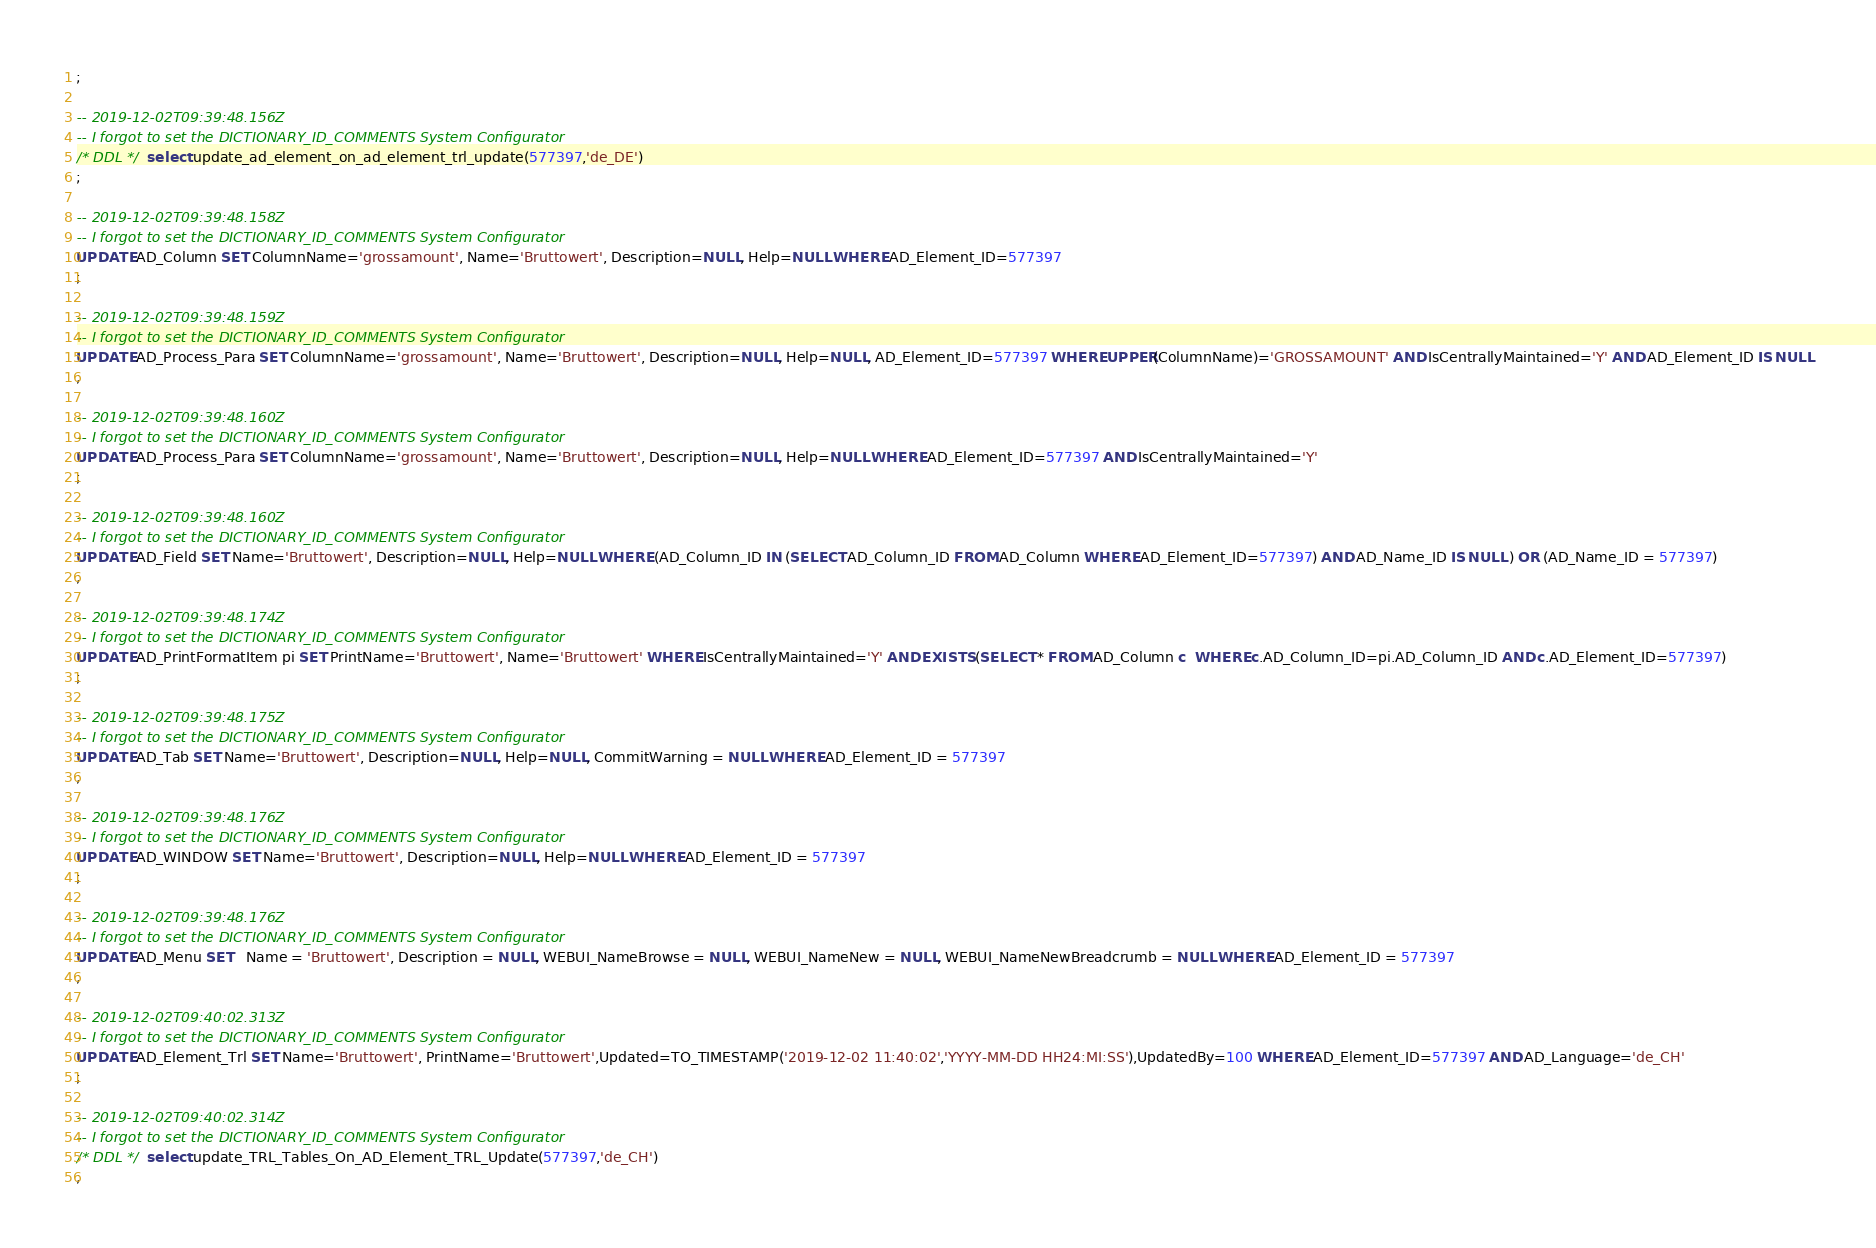<code> <loc_0><loc_0><loc_500><loc_500><_SQL_>;

-- 2019-12-02T09:39:48.156Z
-- I forgot to set the DICTIONARY_ID_COMMENTS System Configurator
/* DDL */  select update_ad_element_on_ad_element_trl_update(577397,'de_DE') 
;

-- 2019-12-02T09:39:48.158Z
-- I forgot to set the DICTIONARY_ID_COMMENTS System Configurator
UPDATE AD_Column SET ColumnName='grossamount', Name='Bruttowert', Description=NULL, Help=NULL WHERE AD_Element_ID=577397
;

-- 2019-12-02T09:39:48.159Z
-- I forgot to set the DICTIONARY_ID_COMMENTS System Configurator
UPDATE AD_Process_Para SET ColumnName='grossamount', Name='Bruttowert', Description=NULL, Help=NULL, AD_Element_ID=577397 WHERE UPPER(ColumnName)='GROSSAMOUNT' AND IsCentrallyMaintained='Y' AND AD_Element_ID IS NULL
;

-- 2019-12-02T09:39:48.160Z
-- I forgot to set the DICTIONARY_ID_COMMENTS System Configurator
UPDATE AD_Process_Para SET ColumnName='grossamount', Name='Bruttowert', Description=NULL, Help=NULL WHERE AD_Element_ID=577397 AND IsCentrallyMaintained='Y'
;

-- 2019-12-02T09:39:48.160Z
-- I forgot to set the DICTIONARY_ID_COMMENTS System Configurator
UPDATE AD_Field SET Name='Bruttowert', Description=NULL, Help=NULL WHERE (AD_Column_ID IN (SELECT AD_Column_ID FROM AD_Column WHERE AD_Element_ID=577397) AND AD_Name_ID IS NULL ) OR (AD_Name_ID = 577397)
;

-- 2019-12-02T09:39:48.174Z
-- I forgot to set the DICTIONARY_ID_COMMENTS System Configurator
UPDATE AD_PrintFormatItem pi SET PrintName='Bruttowert', Name='Bruttowert' WHERE IsCentrallyMaintained='Y' AND EXISTS (SELECT * FROM AD_Column c  WHERE c.AD_Column_ID=pi.AD_Column_ID AND c.AD_Element_ID=577397)
;

-- 2019-12-02T09:39:48.175Z
-- I forgot to set the DICTIONARY_ID_COMMENTS System Configurator
UPDATE AD_Tab SET Name='Bruttowert', Description=NULL, Help=NULL, CommitWarning = NULL WHERE AD_Element_ID = 577397
;

-- 2019-12-02T09:39:48.176Z
-- I forgot to set the DICTIONARY_ID_COMMENTS System Configurator
UPDATE AD_WINDOW SET Name='Bruttowert', Description=NULL, Help=NULL WHERE AD_Element_ID = 577397
;

-- 2019-12-02T09:39:48.176Z
-- I forgot to set the DICTIONARY_ID_COMMENTS System Configurator
UPDATE AD_Menu SET   Name = 'Bruttowert', Description = NULL, WEBUI_NameBrowse = NULL, WEBUI_NameNew = NULL, WEBUI_NameNewBreadcrumb = NULL WHERE AD_Element_ID = 577397
;

-- 2019-12-02T09:40:02.313Z
-- I forgot to set the DICTIONARY_ID_COMMENTS System Configurator
UPDATE AD_Element_Trl SET Name='Bruttowert', PrintName='Bruttowert',Updated=TO_TIMESTAMP('2019-12-02 11:40:02','YYYY-MM-DD HH24:MI:SS'),UpdatedBy=100 WHERE AD_Element_ID=577397 AND AD_Language='de_CH'
;

-- 2019-12-02T09:40:02.314Z
-- I forgot to set the DICTIONARY_ID_COMMENTS System Configurator
/* DDL */  select update_TRL_Tables_On_AD_Element_TRL_Update(577397,'de_CH') 
;

</code> 